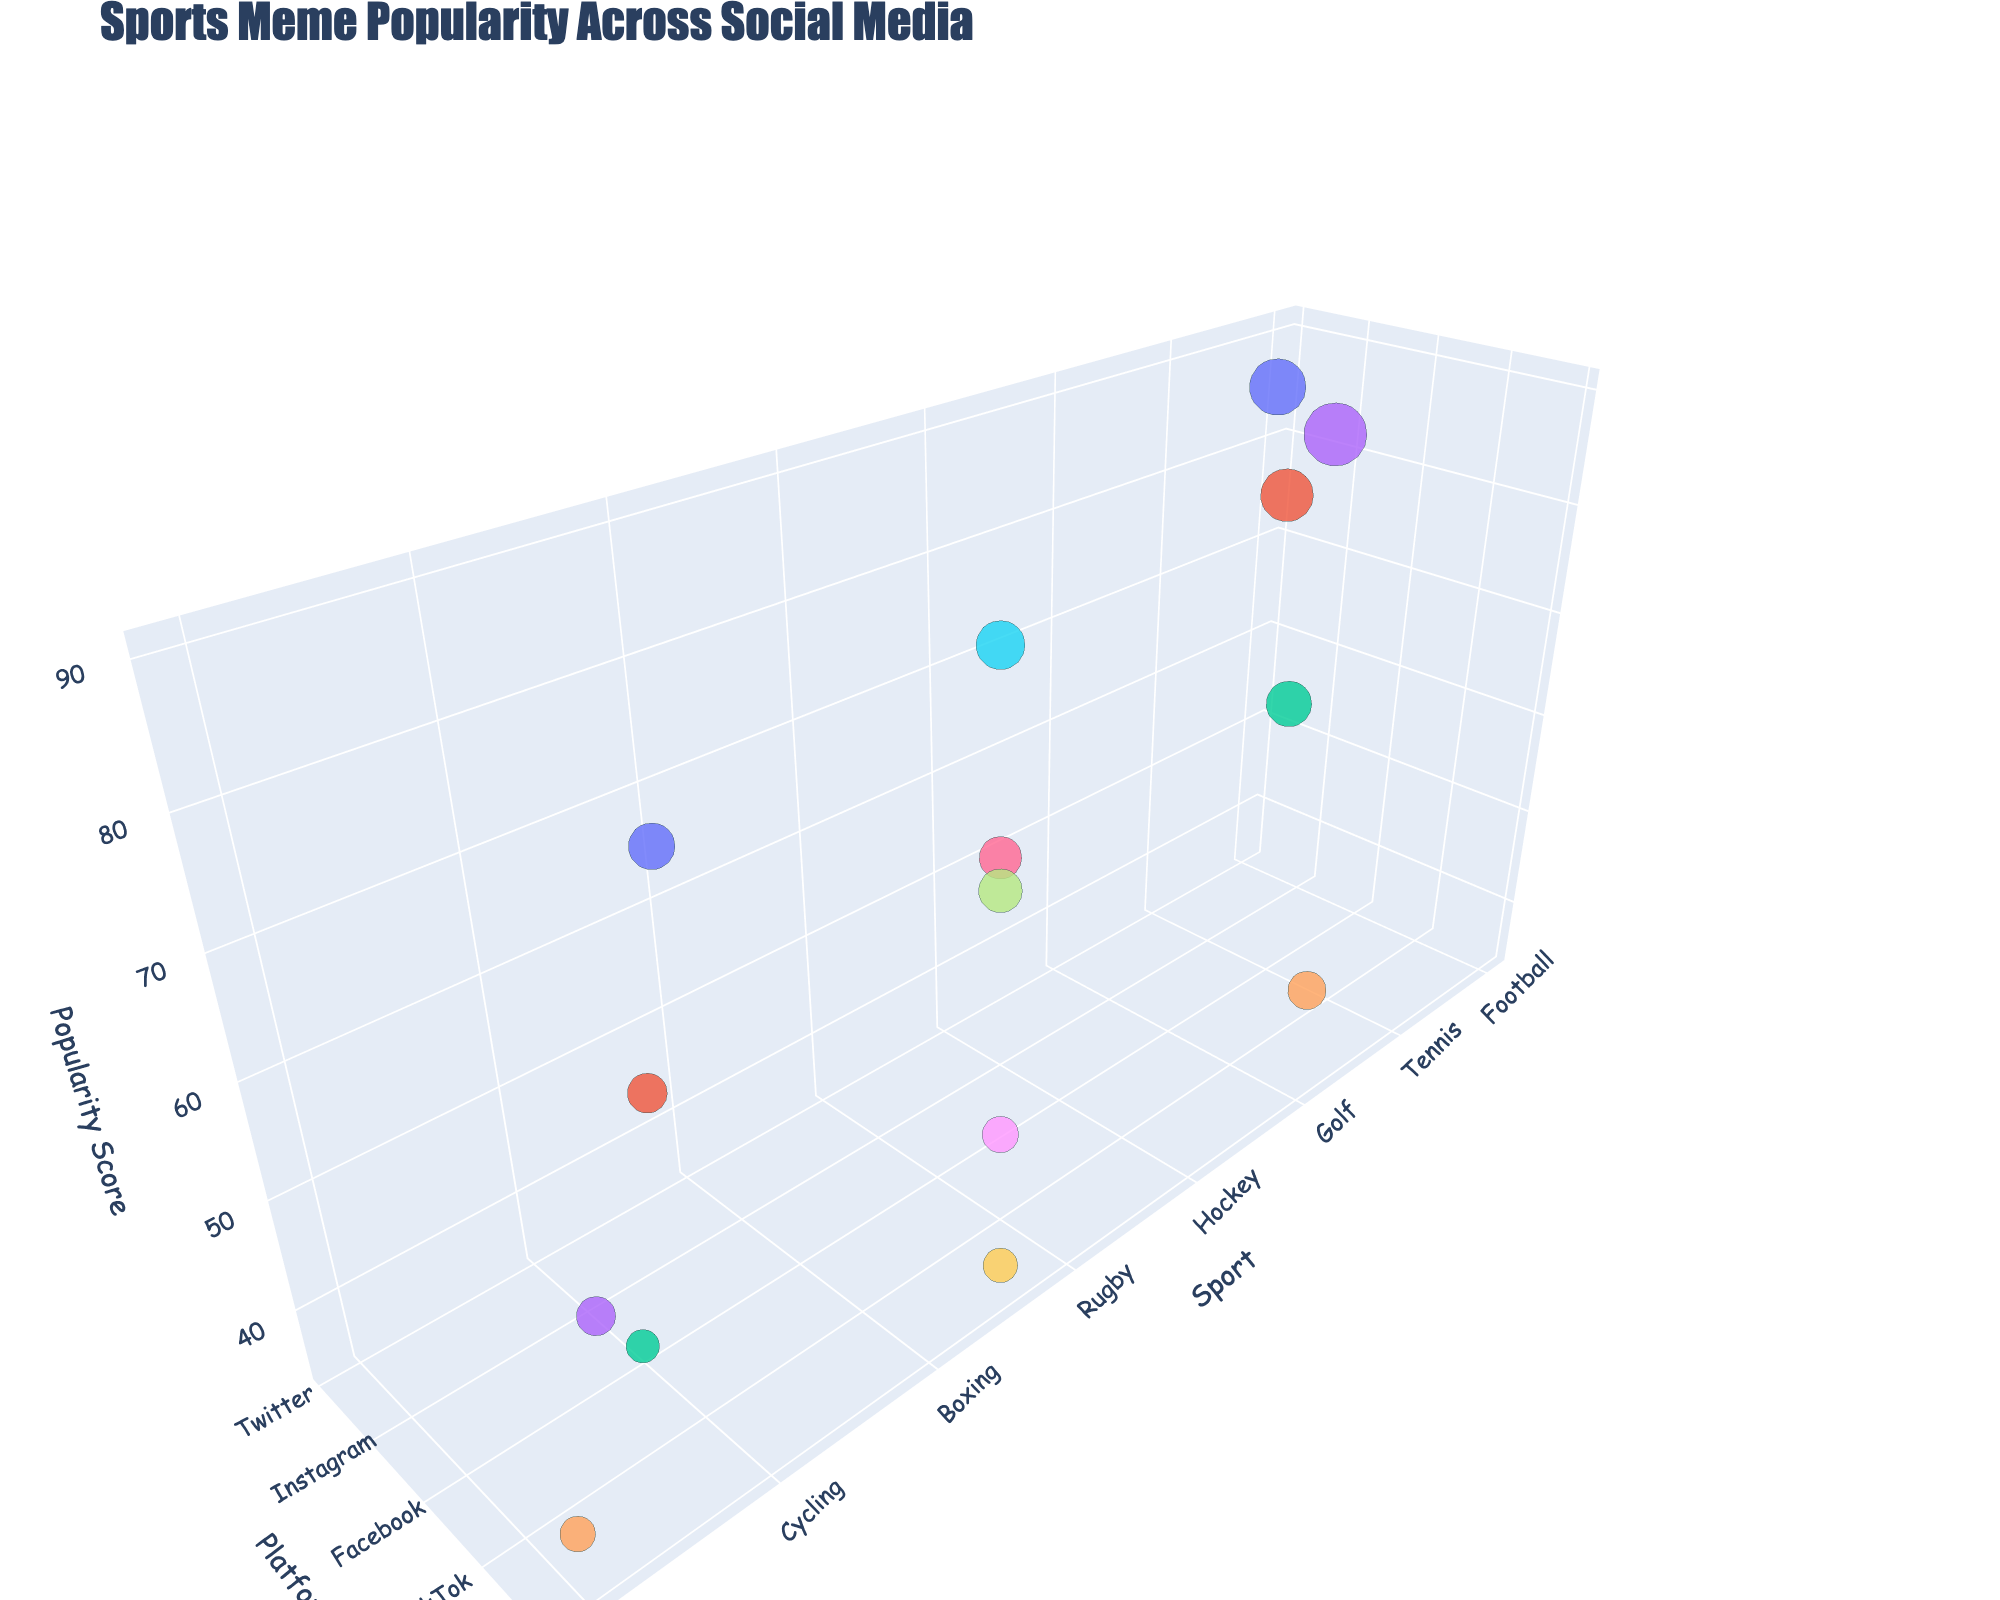What's the title of the figure? The title of the figure is usually found at the top of the chart, indicating what the chart represents. The title here is "Sports Meme Popularity Across Social Media," which informs the viewer that the figure shows how popular sports memes are across different social media platforms.
Answer: Sports Meme Popularity Across Social Media How many sports are represented in the figure? To determine the number of sports represented, we can count the distinct data points along the 'Sport' axis. Each unique sport is shown as a separate bubble within the 3D space.
Answer: 15 Which sport has the highest popularity score on TikTok? To find this, locate the 'TikTok' label along the Platform axis and identify the bubble with the highest position along the 'Popularity' axis. The 'Soccer' bubble is the highest on TikTok in terms of popularity.
Answer: Soccer What platform features golf memes? Identify the golf bubble in the figure and trace it to the corresponding label on the 'Platform' axis. Golf is represented on Reddit in the chart.
Answer: Reddit Which sport has the smallest bubble on Facebook? The size of the bubbles represents the number of memes. On Facebook, identify the smallest bubble, which corresponds to the sport 'Cycling', indicating it has the least number of memes.
Answer: Cycling How does the popularity of Volleyball memes on Instagram compare to those on other platforms? Locate the Volleyball bubble on the Instagram axis and see its position on the 'Popularity' axis in comparison to its counterparts on other platforms. Volleyball has a popularity score of 50 on Instagram and does not appear on other platforms, making this the only available comparison.
Answer: Volleyball is only on Instagram with a popularity of 50 Which two social media platforms feature memes about Rugby, and how do their popularity scores compare? Find the Rugby bubble and note the label on the 'Platform' axis. Rugby memes appear on TikTok and have a popularity score of 42. No other platforms feature Rugby memes. Therefore, no comparison is possible with other platforms.
Answer: TikTok, no comparison is possible What sport on Twitter has the highest popularity score? Look at the Twitter axis and identify the tallest bubble along the 'Popularity' axis. Football is the sport with the highest popularity on Twitter.
Answer: Football How many memes are there about Hockey on Instagram? Locate the Hockey bubble on the Instagram axis and observe its size. From the data, the 'Meme_Count' for Hockey on Instagram is 6800.
Answer: 6800 